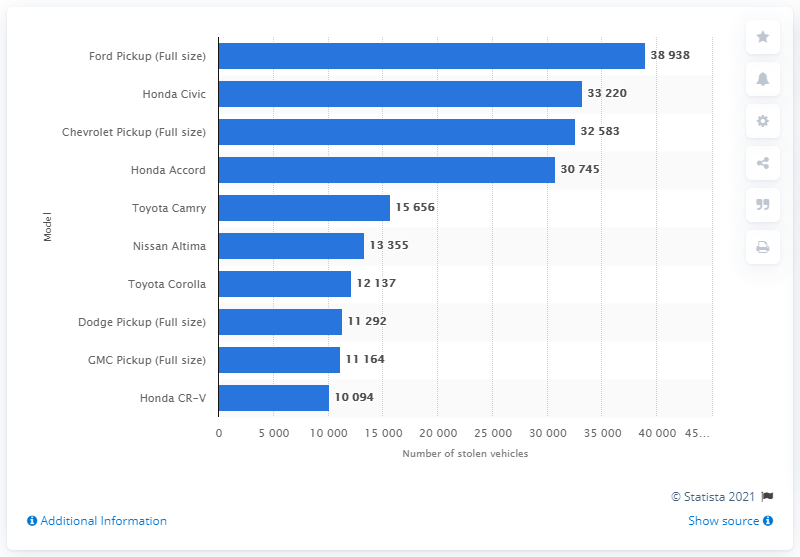Draw attention to some important aspects in this diagram. According to data from 2019, the Honda Civic was the second most stolen vehicle in the United States. 